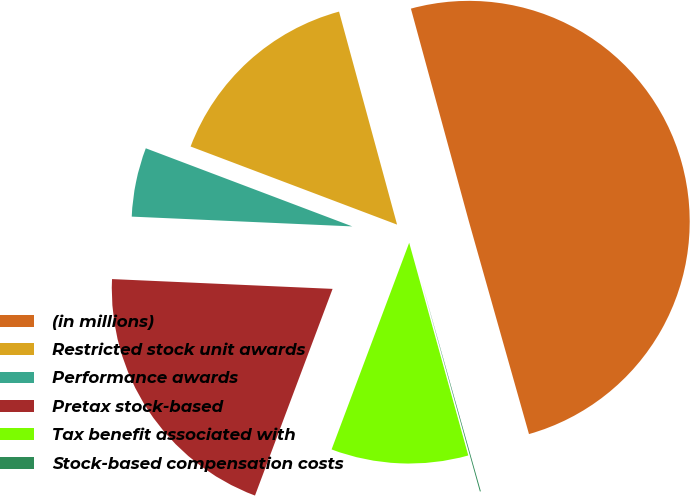<chart> <loc_0><loc_0><loc_500><loc_500><pie_chart><fcel>(in millions)<fcel>Restricted stock unit awards<fcel>Performance awards<fcel>Pretax stock-based<fcel>Tax benefit associated with<fcel>Stock-based compensation costs<nl><fcel>49.85%<fcel>15.01%<fcel>5.05%<fcel>19.99%<fcel>10.03%<fcel>0.07%<nl></chart> 